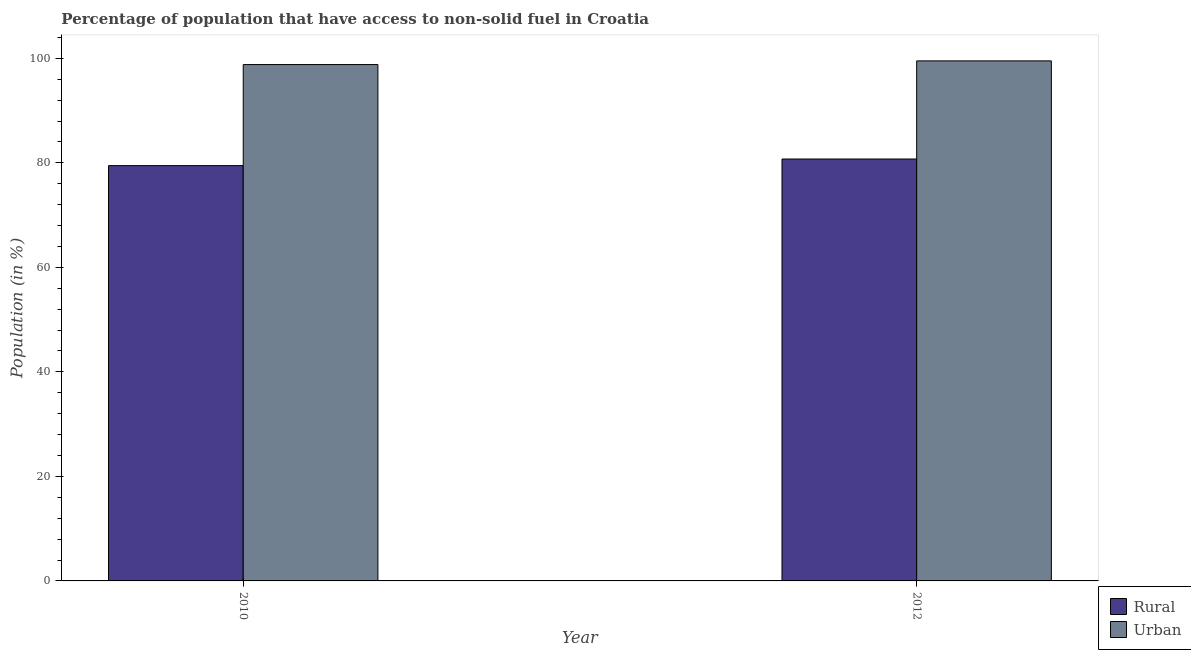How many different coloured bars are there?
Keep it short and to the point. 2. Are the number of bars per tick equal to the number of legend labels?
Offer a very short reply. Yes. Are the number of bars on each tick of the X-axis equal?
Offer a very short reply. Yes. How many bars are there on the 1st tick from the left?
Give a very brief answer. 2. How many bars are there on the 2nd tick from the right?
Offer a very short reply. 2. What is the label of the 2nd group of bars from the left?
Your response must be concise. 2012. What is the urban population in 2010?
Provide a short and direct response. 98.81. Across all years, what is the maximum urban population?
Give a very brief answer. 99.52. Across all years, what is the minimum urban population?
Provide a short and direct response. 98.81. In which year was the rural population maximum?
Offer a terse response. 2012. What is the total urban population in the graph?
Offer a very short reply. 198.33. What is the difference between the urban population in 2010 and that in 2012?
Make the answer very short. -0.71. What is the difference between the rural population in 2012 and the urban population in 2010?
Ensure brevity in your answer.  1.27. What is the average urban population per year?
Your answer should be very brief. 99.16. In the year 2010, what is the difference between the rural population and urban population?
Offer a very short reply. 0. In how many years, is the rural population greater than 48 %?
Offer a very short reply. 2. What is the ratio of the rural population in 2010 to that in 2012?
Make the answer very short. 0.98. What does the 2nd bar from the left in 2010 represents?
Provide a short and direct response. Urban. What does the 2nd bar from the right in 2010 represents?
Give a very brief answer. Rural. What is the difference between two consecutive major ticks on the Y-axis?
Your answer should be very brief. 20. Are the values on the major ticks of Y-axis written in scientific E-notation?
Give a very brief answer. No. Does the graph contain any zero values?
Your answer should be compact. No. How many legend labels are there?
Provide a short and direct response. 2. What is the title of the graph?
Make the answer very short. Percentage of population that have access to non-solid fuel in Croatia. Does "Underweight" appear as one of the legend labels in the graph?
Offer a very short reply. No. What is the label or title of the X-axis?
Your answer should be very brief. Year. What is the label or title of the Y-axis?
Provide a succinct answer. Population (in %). What is the Population (in %) in Rural in 2010?
Provide a succinct answer. 79.47. What is the Population (in %) of Urban in 2010?
Provide a succinct answer. 98.81. What is the Population (in %) of Rural in 2012?
Your response must be concise. 80.74. What is the Population (in %) in Urban in 2012?
Offer a terse response. 99.52. Across all years, what is the maximum Population (in %) of Rural?
Your answer should be compact. 80.74. Across all years, what is the maximum Population (in %) of Urban?
Give a very brief answer. 99.52. Across all years, what is the minimum Population (in %) in Rural?
Provide a succinct answer. 79.47. Across all years, what is the minimum Population (in %) in Urban?
Keep it short and to the point. 98.81. What is the total Population (in %) in Rural in the graph?
Your answer should be compact. 160.21. What is the total Population (in %) of Urban in the graph?
Make the answer very short. 198.33. What is the difference between the Population (in %) in Rural in 2010 and that in 2012?
Provide a succinct answer. -1.27. What is the difference between the Population (in %) of Urban in 2010 and that in 2012?
Your response must be concise. -0.71. What is the difference between the Population (in %) of Rural in 2010 and the Population (in %) of Urban in 2012?
Offer a terse response. -20.04. What is the average Population (in %) in Rural per year?
Keep it short and to the point. 80.11. What is the average Population (in %) in Urban per year?
Your response must be concise. 99.16. In the year 2010, what is the difference between the Population (in %) of Rural and Population (in %) of Urban?
Provide a succinct answer. -19.34. In the year 2012, what is the difference between the Population (in %) in Rural and Population (in %) in Urban?
Your response must be concise. -18.78. What is the ratio of the Population (in %) of Rural in 2010 to that in 2012?
Keep it short and to the point. 0.98. What is the ratio of the Population (in %) of Urban in 2010 to that in 2012?
Ensure brevity in your answer.  0.99. What is the difference between the highest and the second highest Population (in %) in Rural?
Provide a short and direct response. 1.27. What is the difference between the highest and the second highest Population (in %) in Urban?
Your response must be concise. 0.71. What is the difference between the highest and the lowest Population (in %) of Rural?
Give a very brief answer. 1.27. What is the difference between the highest and the lowest Population (in %) in Urban?
Provide a succinct answer. 0.71. 